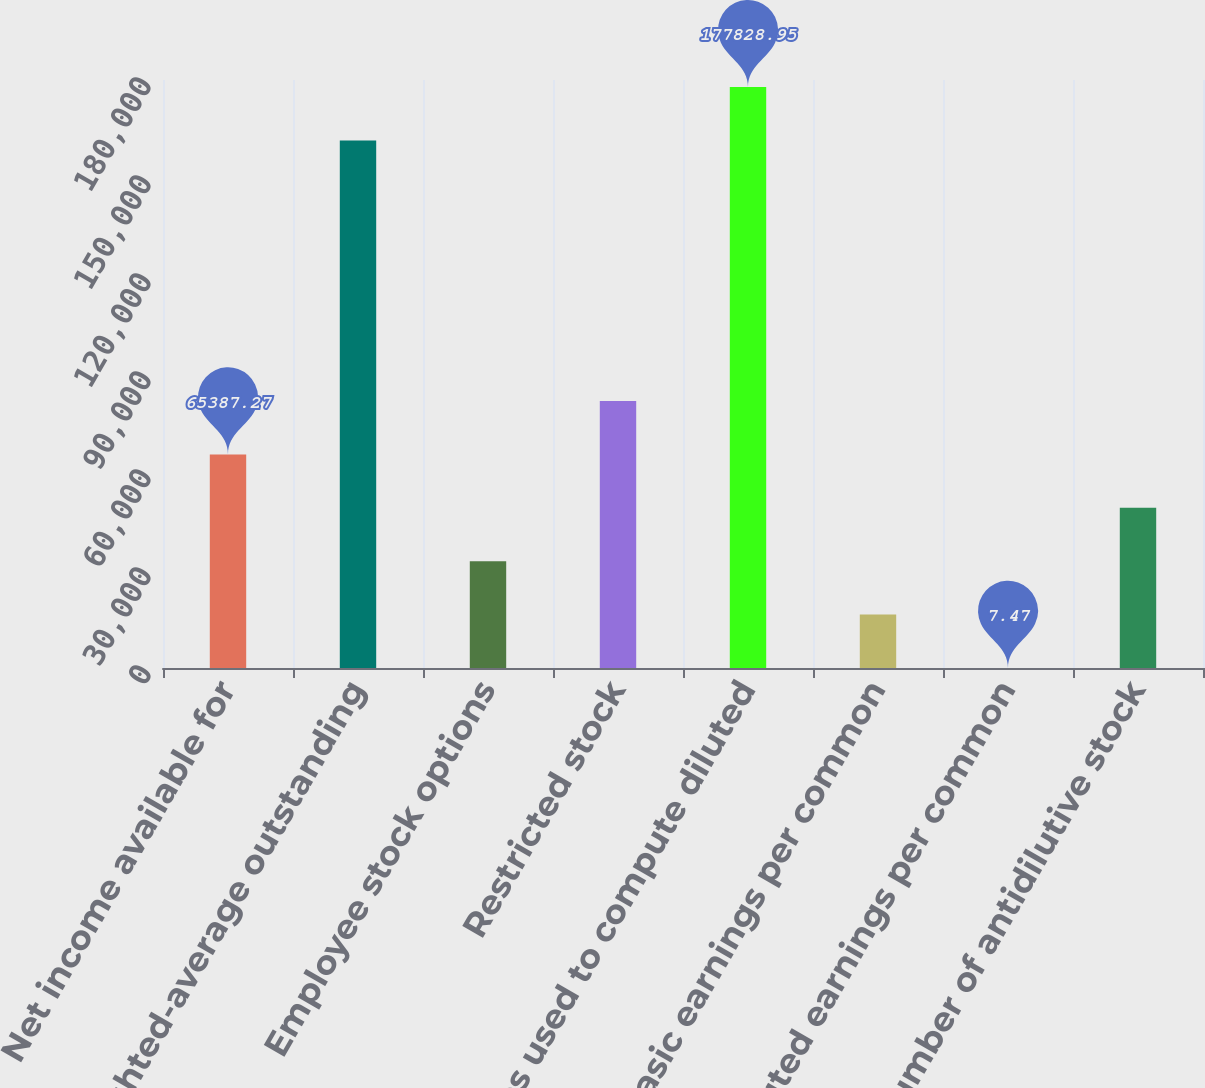Convert chart to OTSL. <chart><loc_0><loc_0><loc_500><loc_500><bar_chart><fcel>Net income available for<fcel>Weighted-average outstanding<fcel>Employee stock options<fcel>Restricted stock<fcel>Shares used to compute diluted<fcel>Basic earnings per common<fcel>Diluted earnings per common<fcel>Number of antidilutive stock<nl><fcel>65387.3<fcel>161484<fcel>32697.4<fcel>81732.2<fcel>177829<fcel>16352.4<fcel>7.47<fcel>49042.3<nl></chart> 